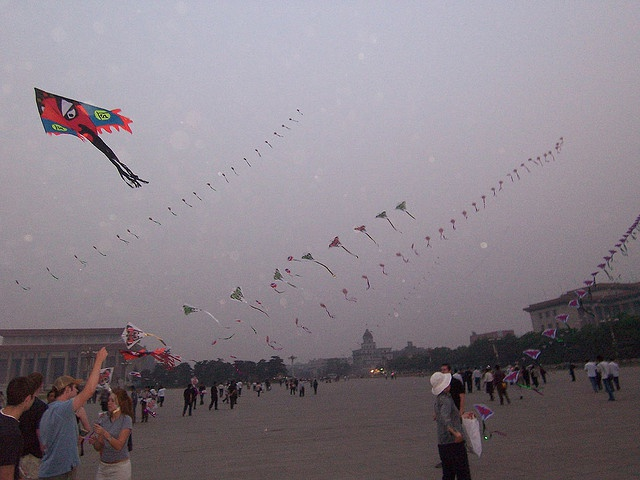Describe the objects in this image and their specific colors. I can see kite in darkgray, gray, and black tones, kite in darkgray, black, brown, and blue tones, people in darkgray, black, and gray tones, people in darkgray, gray, black, and brown tones, and people in darkgray, gray, maroon, black, and brown tones in this image. 